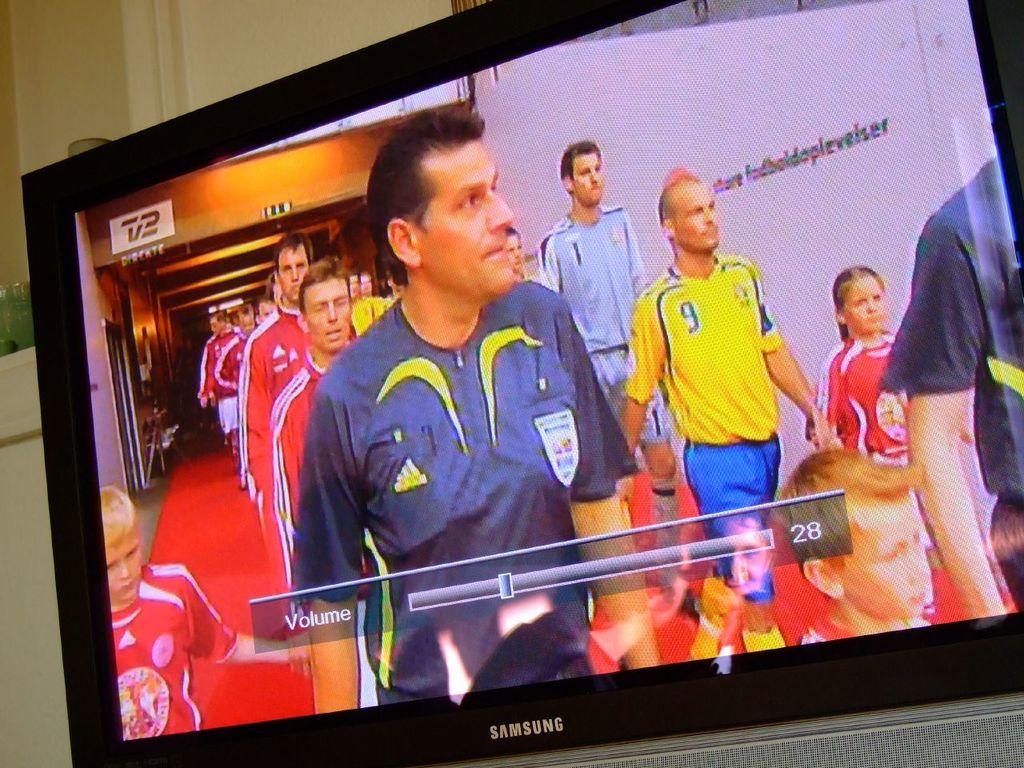What is the brand name of the television?
Give a very brief answer. Samsung. 